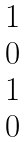Convert formula to latex. <formula><loc_0><loc_0><loc_500><loc_500>\begin{matrix} 1 \\ 0 \\ 1 \\ 0 \end{matrix}</formula> 